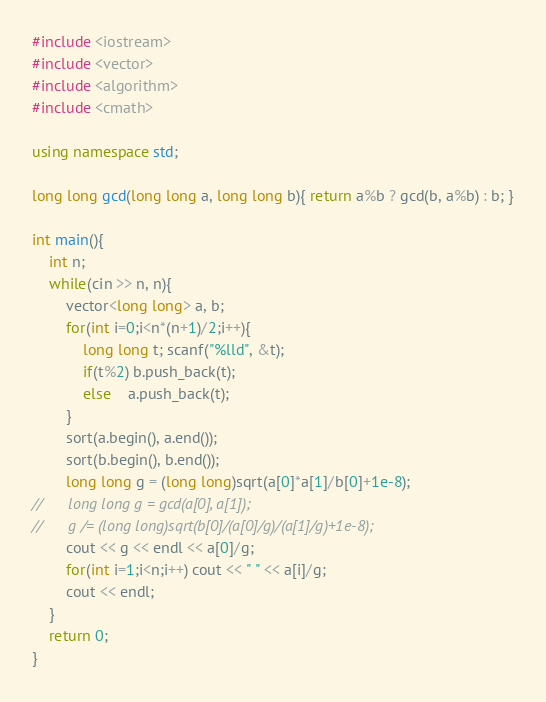Convert code to text. <code><loc_0><loc_0><loc_500><loc_500><_C++_>#include <iostream>
#include <vector>
#include <algorithm>
#include <cmath>

using namespace std;

long long gcd(long long a, long long b){ return a%b ? gcd(b, a%b) : b; }

int main(){
	int n;
	while(cin >> n, n){
		vector<long long> a, b;
		for(int i=0;i<n*(n+1)/2;i++){
			long long t; scanf("%lld", &t);
			if(t%2) b.push_back(t);
			else    a.push_back(t);
		}
		sort(a.begin(), a.end());
		sort(b.begin(), b.end());
		long long g = (long long)sqrt(a[0]*a[1]/b[0]+1e-8);
//		long long g = gcd(a[0], a[1]);
//		g /= (long long)sqrt(b[0]/(a[0]/g)/(a[1]/g)+1e-8);
		cout << g << endl << a[0]/g;
		for(int i=1;i<n;i++) cout << " " << a[i]/g;
		cout << endl;
	}
	return 0;
}</code> 